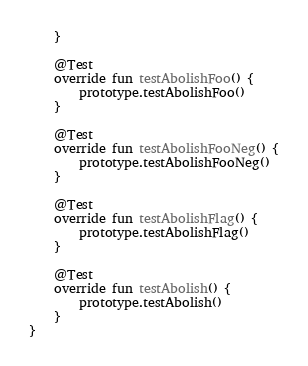<code> <loc_0><loc_0><loc_500><loc_500><_Kotlin_>    }

    @Test
    override fun testAbolishFoo() {
        prototype.testAbolishFoo()
    }

    @Test
    override fun testAbolishFooNeg() {
        prototype.testAbolishFooNeg()
    }

    @Test
    override fun testAbolishFlag() {
        prototype.testAbolishFlag()
    }

    @Test
    override fun testAbolish() {
        prototype.testAbolish()
    }
}
</code> 